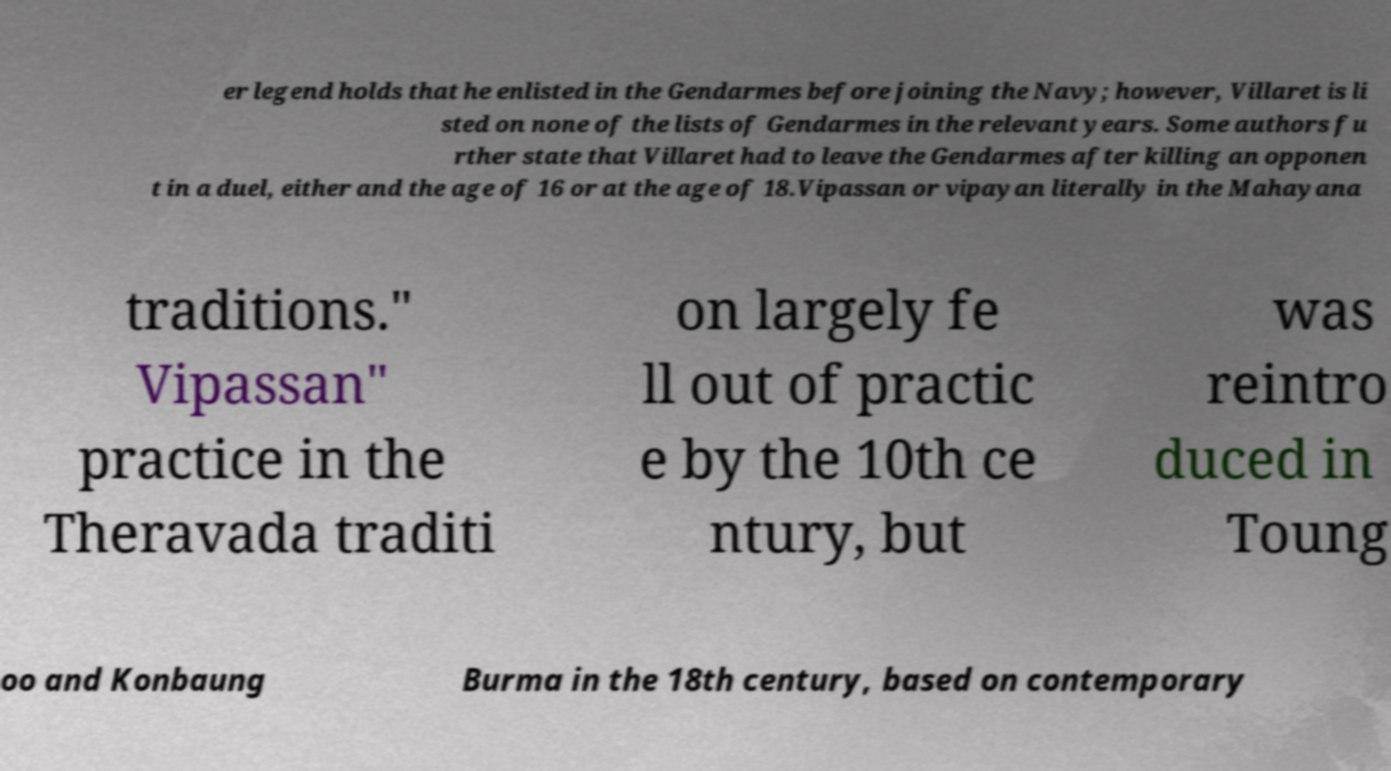Could you assist in decoding the text presented in this image and type it out clearly? er legend holds that he enlisted in the Gendarmes before joining the Navy; however, Villaret is li sted on none of the lists of Gendarmes in the relevant years. Some authors fu rther state that Villaret had to leave the Gendarmes after killing an opponen t in a duel, either and the age of 16 or at the age of 18.Vipassan or vipayan literally in the Mahayana traditions." Vipassan" practice in the Theravada traditi on largely fe ll out of practic e by the 10th ce ntury, but was reintro duced in Toung oo and Konbaung Burma in the 18th century, based on contemporary 